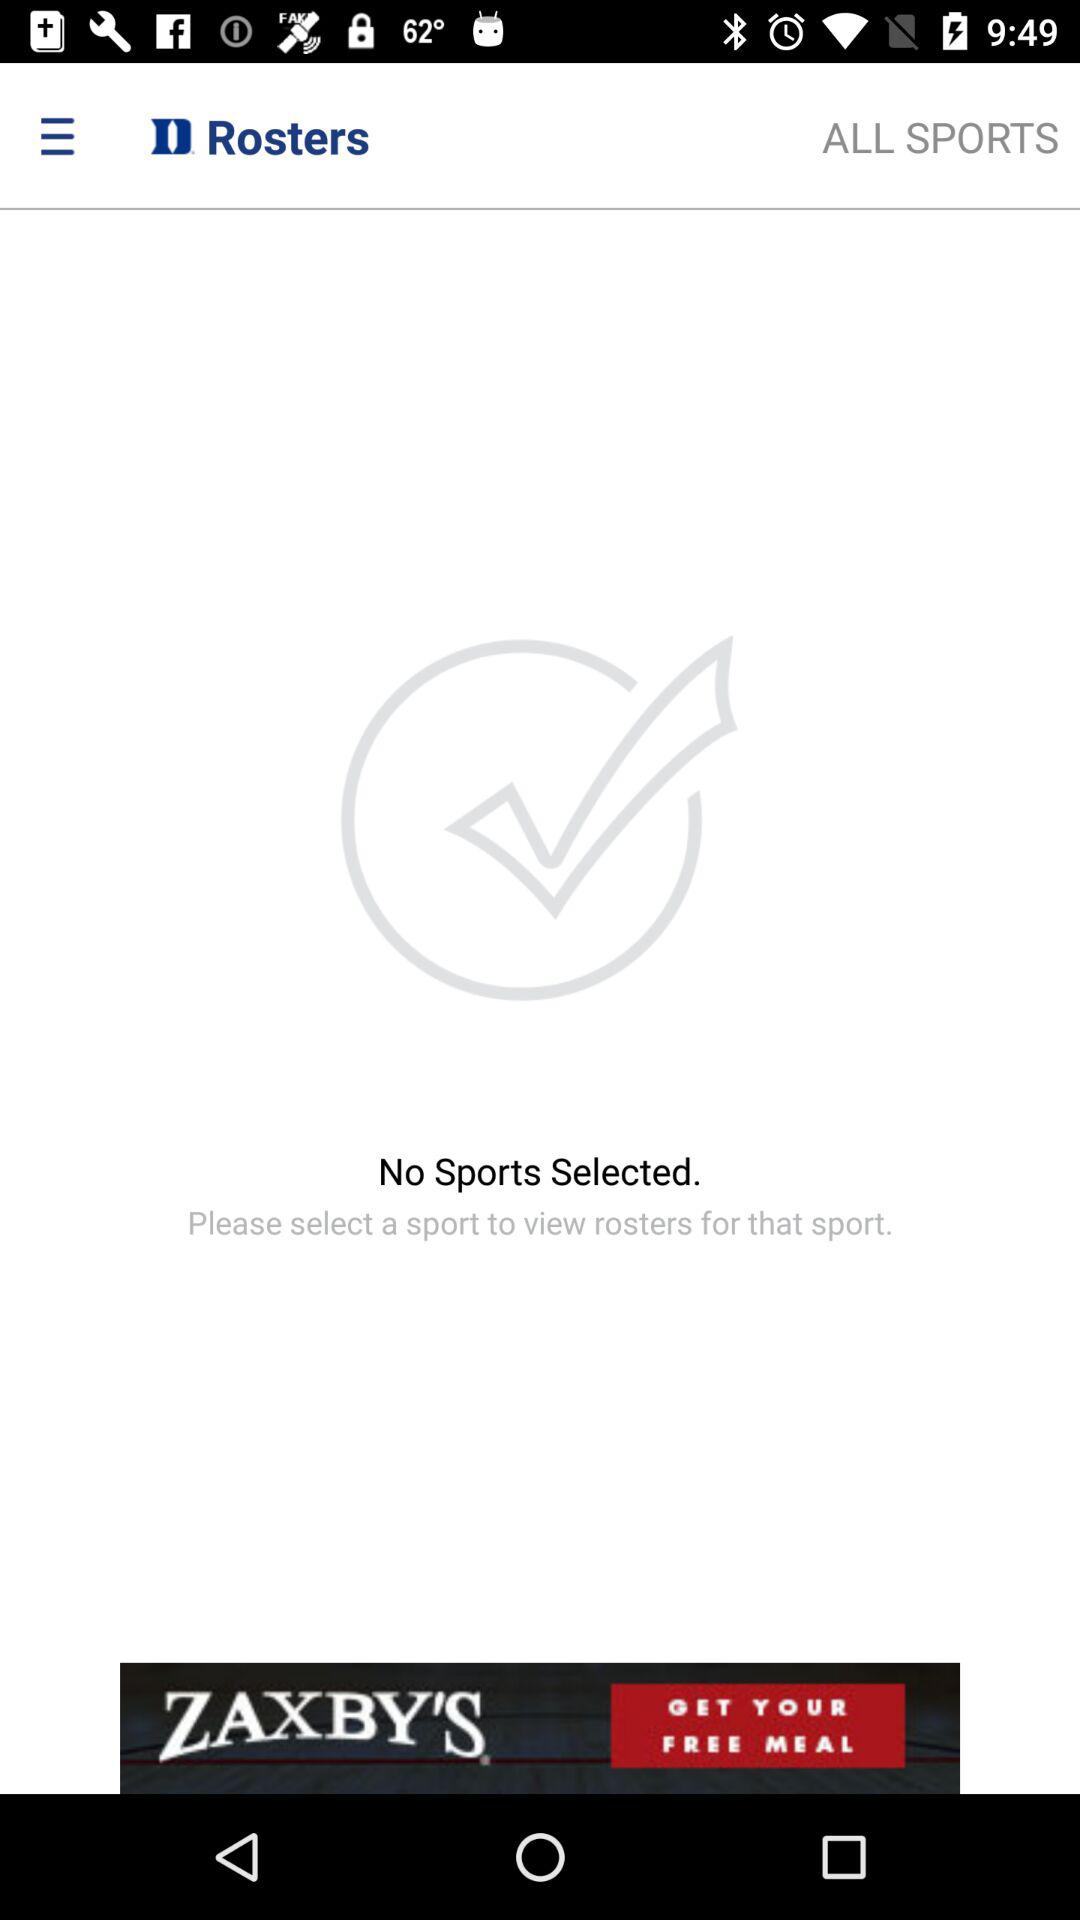Which sports are marked as favorites?
When the provided information is insufficient, respond with <no answer>. <no answer> 